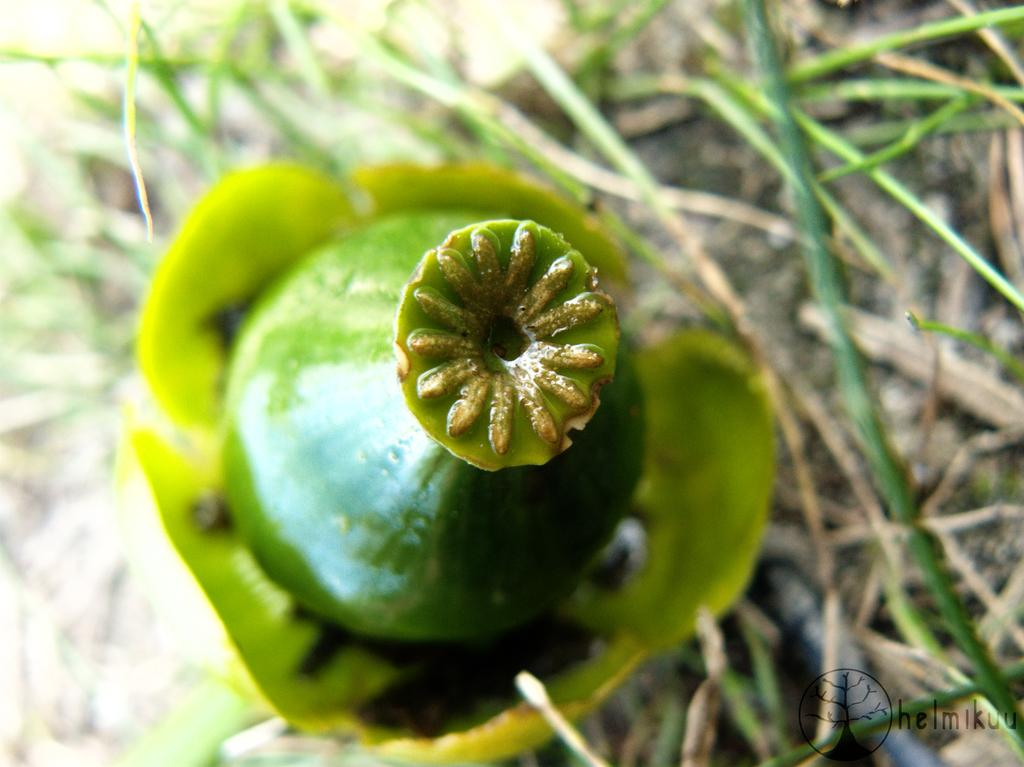What is the main subject of the image? The main subject of the image is a bud. Can you describe the color of the bud? The bud is green in color. What type of guitar is being played by the fly in the image? There is no guitar or fly present in the image; it only features a green bud. 